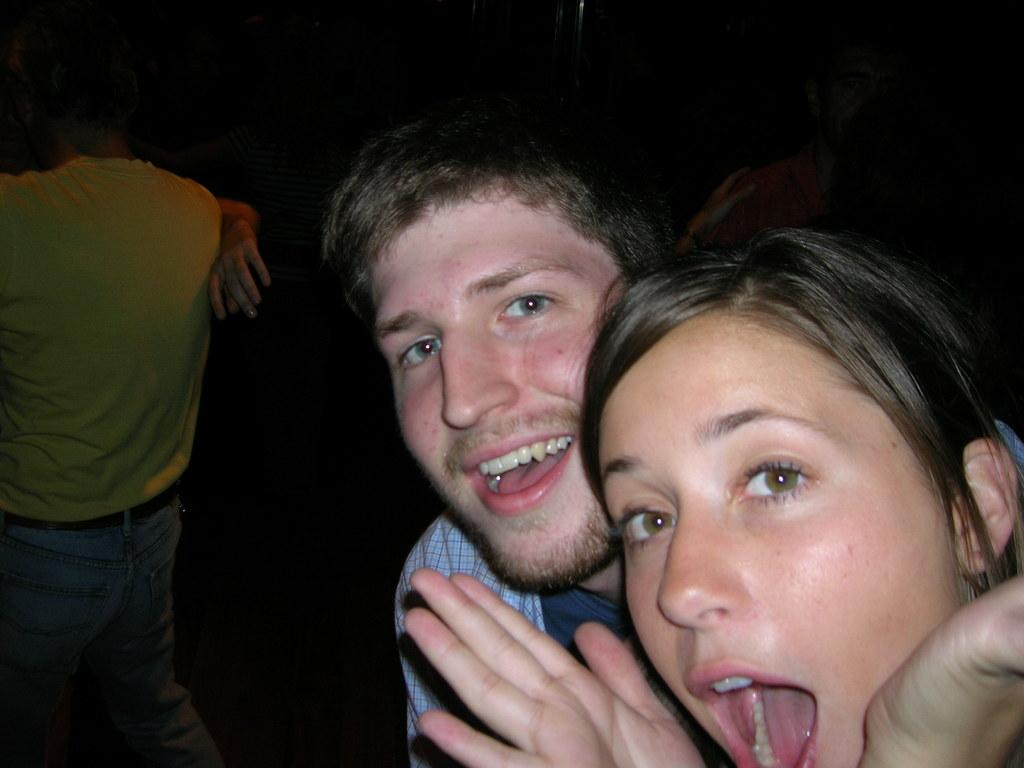Who are the people standing on the right side of the image? There is a woman and a man standing on the right side of the image. What are the other people in the image doing? There are two couples dancing in the background of the image. Can you describe the setting of the image? The image appears to be set in a dark environment. What type of oil can be seen dripping from the plane in the image? There is no plane present in the image, so there is no oil dripping from it. How many crows are visible in the image? There are no crows present in the image. 